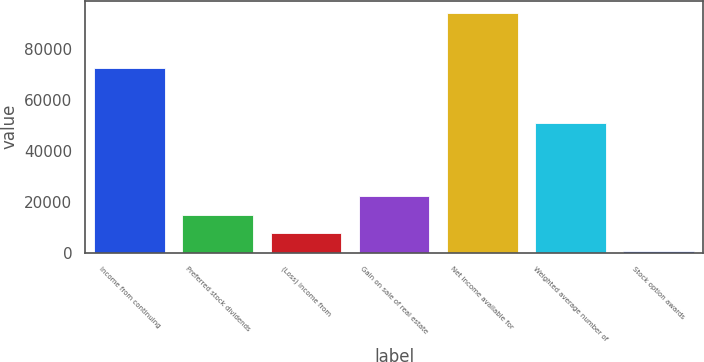Convert chart. <chart><loc_0><loc_0><loc_500><loc_500><bar_chart><fcel>Income from continuing<fcel>Preferred stock dividends<fcel>(Loss) income from<fcel>Gain on sale of real estate<fcel>Net income available for<fcel>Weighted average number of<fcel>Stock option awards<nl><fcel>72650.6<fcel>14967.4<fcel>7753.2<fcel>22181.6<fcel>94293.2<fcel>51008<fcel>539<nl></chart> 